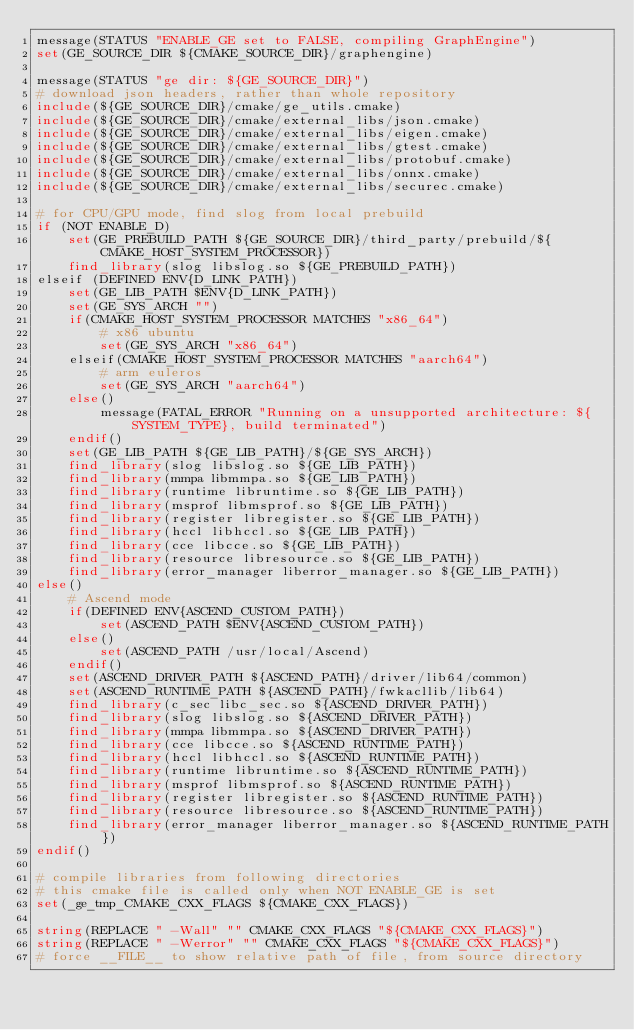Convert code to text. <code><loc_0><loc_0><loc_500><loc_500><_CMake_>message(STATUS "ENABLE_GE set to FALSE, compiling GraphEngine")
set(GE_SOURCE_DIR ${CMAKE_SOURCE_DIR}/graphengine)

message(STATUS "ge dir: ${GE_SOURCE_DIR}")
# download json headers, rather than whole repository
include(${GE_SOURCE_DIR}/cmake/ge_utils.cmake)
include(${GE_SOURCE_DIR}/cmake/external_libs/json.cmake)
include(${GE_SOURCE_DIR}/cmake/external_libs/eigen.cmake)
include(${GE_SOURCE_DIR}/cmake/external_libs/gtest.cmake)
include(${GE_SOURCE_DIR}/cmake/external_libs/protobuf.cmake)
include(${GE_SOURCE_DIR}/cmake/external_libs/onnx.cmake)
include(${GE_SOURCE_DIR}/cmake/external_libs/securec.cmake)

# for CPU/GPU mode, find slog from local prebuild
if (NOT ENABLE_D)
    set(GE_PREBUILD_PATH ${GE_SOURCE_DIR}/third_party/prebuild/${CMAKE_HOST_SYSTEM_PROCESSOR})
    find_library(slog libslog.so ${GE_PREBUILD_PATH})
elseif (DEFINED ENV{D_LINK_PATH})
    set(GE_LIB_PATH $ENV{D_LINK_PATH})
    set(GE_SYS_ARCH "")
    if(CMAKE_HOST_SYSTEM_PROCESSOR MATCHES "x86_64")
        # x86 ubuntu
        set(GE_SYS_ARCH "x86_64")
    elseif(CMAKE_HOST_SYSTEM_PROCESSOR MATCHES "aarch64")
        # arm euleros
        set(GE_SYS_ARCH "aarch64")
    else()
        message(FATAL_ERROR "Running on a unsupported architecture: ${SYSTEM_TYPE}, build terminated")
    endif()
    set(GE_LIB_PATH ${GE_LIB_PATH}/${GE_SYS_ARCH})
    find_library(slog libslog.so ${GE_LIB_PATH})
    find_library(mmpa libmmpa.so ${GE_LIB_PATH})
    find_library(runtime libruntime.so ${GE_LIB_PATH})
    find_library(msprof libmsprof.so ${GE_LIB_PATH})
    find_library(register libregister.so ${GE_LIB_PATH})
    find_library(hccl libhccl.so ${GE_LIB_PATH})
    find_library(cce libcce.so ${GE_LIB_PATH})
    find_library(resource libresource.so ${GE_LIB_PATH})
    find_library(error_manager liberror_manager.so ${GE_LIB_PATH})
else()
    # Ascend mode
    if(DEFINED ENV{ASCEND_CUSTOM_PATH})
        set(ASCEND_PATH $ENV{ASCEND_CUSTOM_PATH})
    else()
        set(ASCEND_PATH /usr/local/Ascend)
    endif()
    set(ASCEND_DRIVER_PATH ${ASCEND_PATH}/driver/lib64/common)
    set(ASCEND_RUNTIME_PATH ${ASCEND_PATH}/fwkacllib/lib64)
    find_library(c_sec libc_sec.so ${ASCEND_DRIVER_PATH})
    find_library(slog libslog.so ${ASCEND_DRIVER_PATH})
    find_library(mmpa libmmpa.so ${ASCEND_DRIVER_PATH})
    find_library(cce libcce.so ${ASCEND_RUNTIME_PATH})
    find_library(hccl libhccl.so ${ASCEND_RUNTIME_PATH})
    find_library(runtime libruntime.so ${ASCEND_RUNTIME_PATH})
    find_library(msprof libmsprof.so ${ASCEND_RUNTIME_PATH})
    find_library(register libregister.so ${ASCEND_RUNTIME_PATH})
    find_library(resource libresource.so ${ASCEND_RUNTIME_PATH})
    find_library(error_manager liberror_manager.so ${ASCEND_RUNTIME_PATH})
endif()

# compile libraries from following directories
# this cmake file is called only when NOT ENABLE_GE is set
set(_ge_tmp_CMAKE_CXX_FLAGS ${CMAKE_CXX_FLAGS})

string(REPLACE " -Wall" "" CMAKE_CXX_FLAGS "${CMAKE_CXX_FLAGS}")
string(REPLACE " -Werror" "" CMAKE_CXX_FLAGS "${CMAKE_CXX_FLAGS}")
# force __FILE__ to show relative path of file, from source directory</code> 